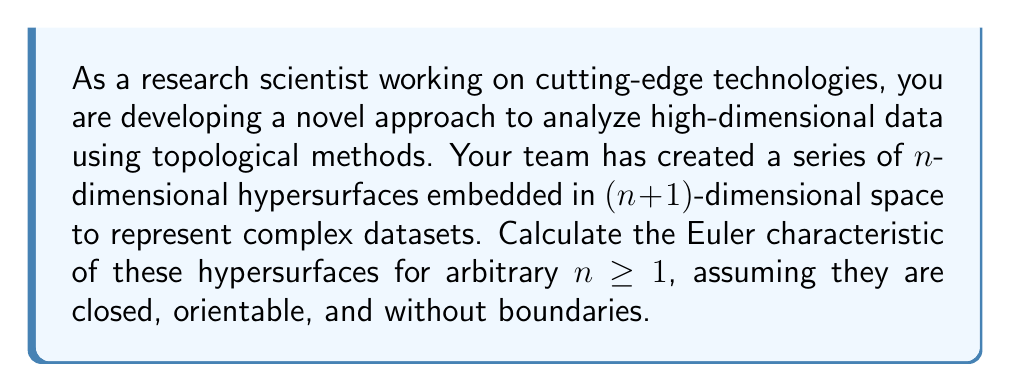Can you solve this math problem? To calculate the Euler characteristic of $n$-dimensional hypersurfaces, we'll use the following steps:

1) Recall the generalized Euler characteristic formula for even-dimensional manifolds:
   
   $$\chi(M^{2k}) = 2 - 2g + \sum_{i=1}^{k-1} (-1)^i b_{2i}$$

   where $g$ is the genus and $b_{2i}$ are the even Betti numbers.

2) For odd-dimensional manifolds, the Euler characteristic is always zero:
   
   $$\chi(M^{2k+1}) = 0$$

3) In our case, we're dealing with $n$-dimensional hypersurfaces embedded in $(n+1)$-dimensional space. These are essentially $n$-spheres (or their topological equivalents).

4) For $n$-spheres:
   - All Betti numbers are 0 except $b_0 = b_n = 1$
   - The genus $g = 0$ (for $n > 1$)

5) Let's consider cases:

   For $n = 2k$ (even dimensions):
   $$\chi(S^{2k}) = 2 - 2(0) + (-1)^0 b_0 + (-1)^k b_{2k} = 2 + 1 + (-1)^k = 1 + (-1)^k + 1 = 2 + (-1)^k$$

   For $n = 2k+1$ (odd dimensions):
   $$\chi(S^{2k+1}) = 0$$

6) We can combine these into a single formula using the floor function:

   $$\chi(S^n) = 1 + (-1)^n$$

This formula works for all $n \geq 1$ and gives the correct result for both even and odd dimensions.
Answer: The Euler characteristic of an $n$-dimensional hypersurface (n-sphere) for $n \geq 1$ is:

$$\chi(S^n) = 1 + (-1)^n$$ 